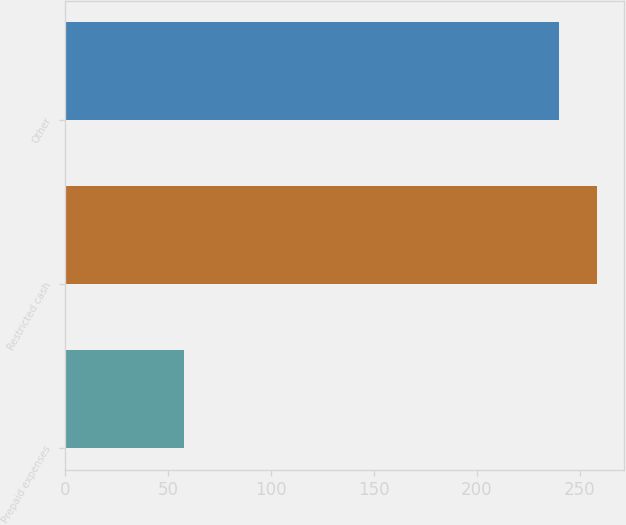Convert chart to OTSL. <chart><loc_0><loc_0><loc_500><loc_500><bar_chart><fcel>Prepaid expenses<fcel>Restricted cash<fcel>Other<nl><fcel>58<fcel>258.5<fcel>240<nl></chart> 